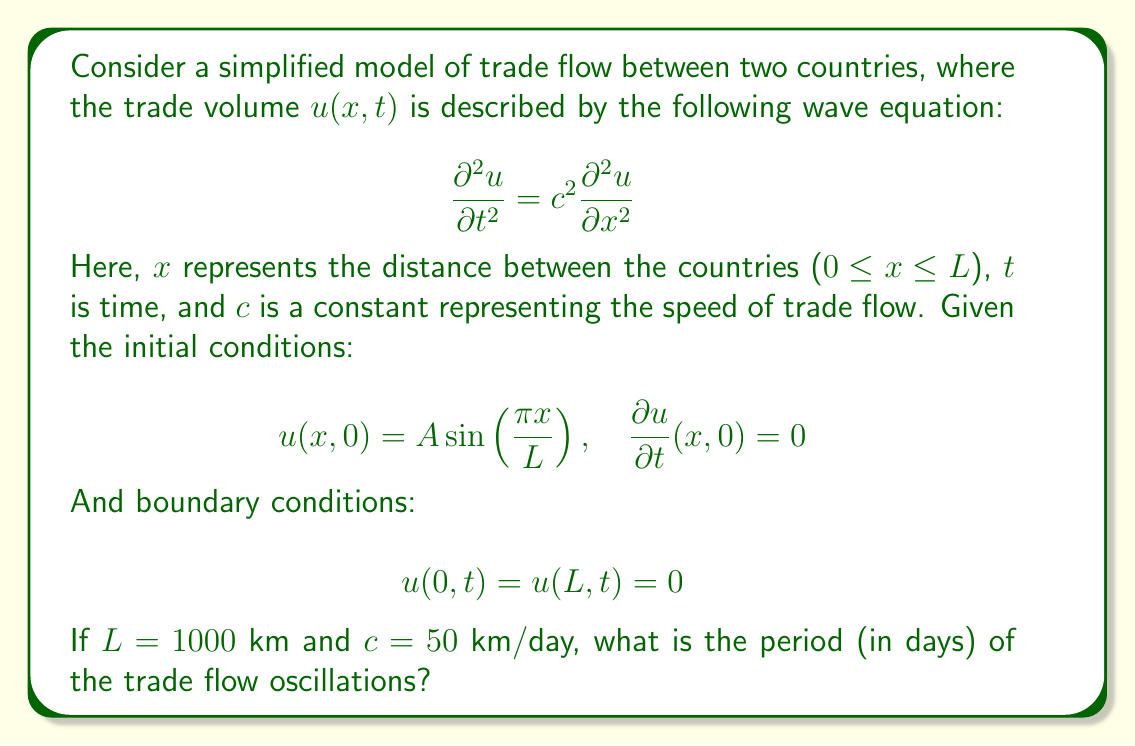Can you answer this question? To solve this problem, we'll follow these steps:

1) The general solution for the wave equation with the given boundary conditions is:

   $$u(x,t) = \sum_{n=1}^{\infty} (A_n \cos(\omega_n t) + B_n \sin(\omega_n t)) \sin(\frac{n\pi x}{L})$$

   where $\omega_n = \frac{n\pi c}{L}$

2) Given the initial conditions, we can see that only the first term (n=1) is present, and B_1 = 0. So our solution simplifies to:

   $$u(x,t) = A \cos(\omega_1 t) \sin(\frac{\pi x}{L})$$

3) The angular frequency $\omega_1$ is:

   $$\omega_1 = \frac{\pi c}{L}$$

4) We can calculate this with the given values:

   $$\omega_1 = \frac{\pi \cdot 50}{1000} = \frac{\pi}{20} \approx 0.1571 \text{ rad/day}$$

5) The period T is related to the angular frequency by:

   $$T = \frac{2\pi}{\omega_1}$$

6) Substituting our value for $\omega_1$:

   $$T = \frac{2\pi}{\frac{\pi}{20}} = 40 \text{ days}$$

Therefore, the period of the trade flow oscillations is 40 days.
Answer: 40 days 